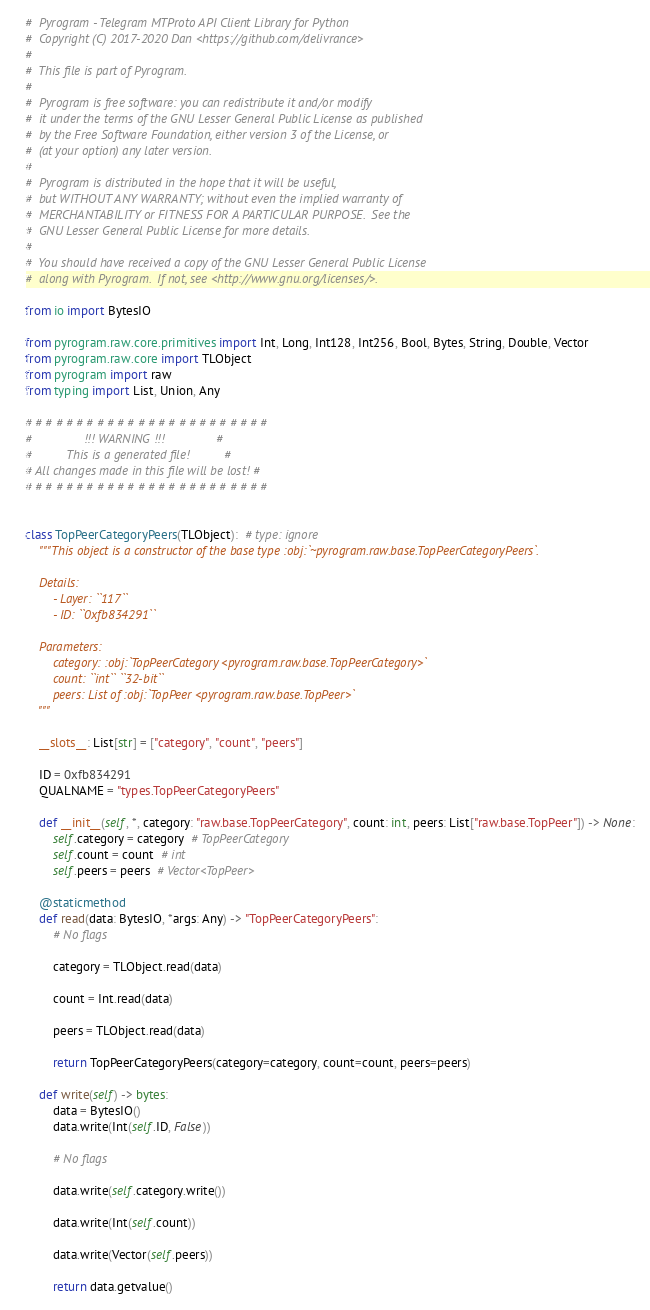Convert code to text. <code><loc_0><loc_0><loc_500><loc_500><_Python_>#  Pyrogram - Telegram MTProto API Client Library for Python
#  Copyright (C) 2017-2020 Dan <https://github.com/delivrance>
#
#  This file is part of Pyrogram.
#
#  Pyrogram is free software: you can redistribute it and/or modify
#  it under the terms of the GNU Lesser General Public License as published
#  by the Free Software Foundation, either version 3 of the License, or
#  (at your option) any later version.
#
#  Pyrogram is distributed in the hope that it will be useful,
#  but WITHOUT ANY WARRANTY; without even the implied warranty of
#  MERCHANTABILITY or FITNESS FOR A PARTICULAR PURPOSE.  See the
#  GNU Lesser General Public License for more details.
#
#  You should have received a copy of the GNU Lesser General Public License
#  along with Pyrogram.  If not, see <http://www.gnu.org/licenses/>.

from io import BytesIO

from pyrogram.raw.core.primitives import Int, Long, Int128, Int256, Bool, Bytes, String, Double, Vector
from pyrogram.raw.core import TLObject
from pyrogram import raw
from typing import List, Union, Any

# # # # # # # # # # # # # # # # # # # # # # # #
#               !!! WARNING !!!               #
#          This is a generated file!          #
# All changes made in this file will be lost! #
# # # # # # # # # # # # # # # # # # # # # # # #


class TopPeerCategoryPeers(TLObject):  # type: ignore
    """This object is a constructor of the base type :obj:`~pyrogram.raw.base.TopPeerCategoryPeers`.

    Details:
        - Layer: ``117``
        - ID: ``0xfb834291``

    Parameters:
        category: :obj:`TopPeerCategory <pyrogram.raw.base.TopPeerCategory>`
        count: ``int`` ``32-bit``
        peers: List of :obj:`TopPeer <pyrogram.raw.base.TopPeer>`
    """

    __slots__: List[str] = ["category", "count", "peers"]

    ID = 0xfb834291
    QUALNAME = "types.TopPeerCategoryPeers"

    def __init__(self, *, category: "raw.base.TopPeerCategory", count: int, peers: List["raw.base.TopPeer"]) -> None:
        self.category = category  # TopPeerCategory
        self.count = count  # int
        self.peers = peers  # Vector<TopPeer>

    @staticmethod
    def read(data: BytesIO, *args: Any) -> "TopPeerCategoryPeers":
        # No flags
        
        category = TLObject.read(data)
        
        count = Int.read(data)
        
        peers = TLObject.read(data)
        
        return TopPeerCategoryPeers(category=category, count=count, peers=peers)

    def write(self) -> bytes:
        data = BytesIO()
        data.write(Int(self.ID, False))

        # No flags
        
        data.write(self.category.write())
        
        data.write(Int(self.count))
        
        data.write(Vector(self.peers))
        
        return data.getvalue()
</code> 